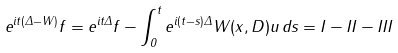Convert formula to latex. <formula><loc_0><loc_0><loc_500><loc_500>e ^ { i t ( \Delta - W ) } f = e ^ { i t \Delta } f - \int _ { 0 } ^ { t } e ^ { i ( t - s ) \Delta } W ( x , D ) u \, d s = I - I I - I I I</formula> 